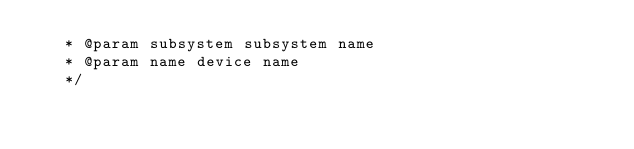<code> <loc_0><loc_0><loc_500><loc_500><_C_>   * @param subsystem subsystem name
   * @param name device name
   */</code> 